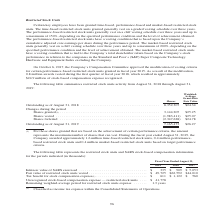From Jabil Circuit's financial document, Which dates does the table provide data for outstanding restricted stock units for? The document shows two values: August 31, 2018 and August 31, 2019. From the document: "Outstanding as of August 31, 2019 . 7,165,473 $26.27 Outstanding as of August 31, 2018 . 8,352,307 $24.34 Changes during the period Shares granted (1)..." Also, What does the amount for shares granted that are based on the achievement of certain performance criteria represent? the maximum number of shares that can vest.. The document states: "ertain performance criteria, the amount represents the maximum number of shares that can vest. During the fiscal year ended August 31, 2019, the Compa..." Also, What was the amount of shares forfeited? According to the financial document, (2,347,628). The relevant text states: "res vested . (1,983,411) $25.07 Shares forfeited . (2,347,628) $24.78..." Also, can you calculate: What was the average fair weighted average grant-date fair value between shares granted, vested and forfeited? To answer this question, I need to perform calculations using the financial data. The calculation is: ($25.25+$25.07+$24.78)/(2019-2018+2), which equals 25.03. This is based on the information: "Outstanding as of August 31, 2018 . 8,352,307 $24.34 Changes during the period Shares granted (1) . 3,144,205 $25.25 Shares vested . ) . 3,144,205 $25.25 Shares vested . (1,983,411) $25.07 Shares forf..." The key data points involved are: 2018, 2019, 24.78. Also, can you calculate: What was the change in the weighted average grant-date fair value between 2018 and 2019? Based on the calculation: $26.27-$24.34, the result is 1.93. This is based on the information: "Outstanding as of August 31, 2019 . 7,165,473 $26.27 Outstanding as of August 31, 2018 . 8,352,307 $24.34 Changes during the period Shares granted (1) . 3,144,205 $25.25 Shares vested . (1,983,411) $2..." The key data points involved are: 24.34, 26.27. Also, can you calculate: What was the percentage change in the number of shares between 2018 and 2019? To answer this question, I need to perform calculations using the financial data. The calculation is: (7,165,473-8,352,307)/8,352,307, which equals -14.21 (percentage). This is based on the information: "Outstanding as of August 31, 2018 . 8,352,307 $24.34 Changes during the period Shares granted (1) . 3,144,205 $25.25 Shares vested . (1,983,411) Outstanding as of August 31, 2019 . 7,165,473 $26.27..." The key data points involved are: 7,165,473, 8,352,307. 